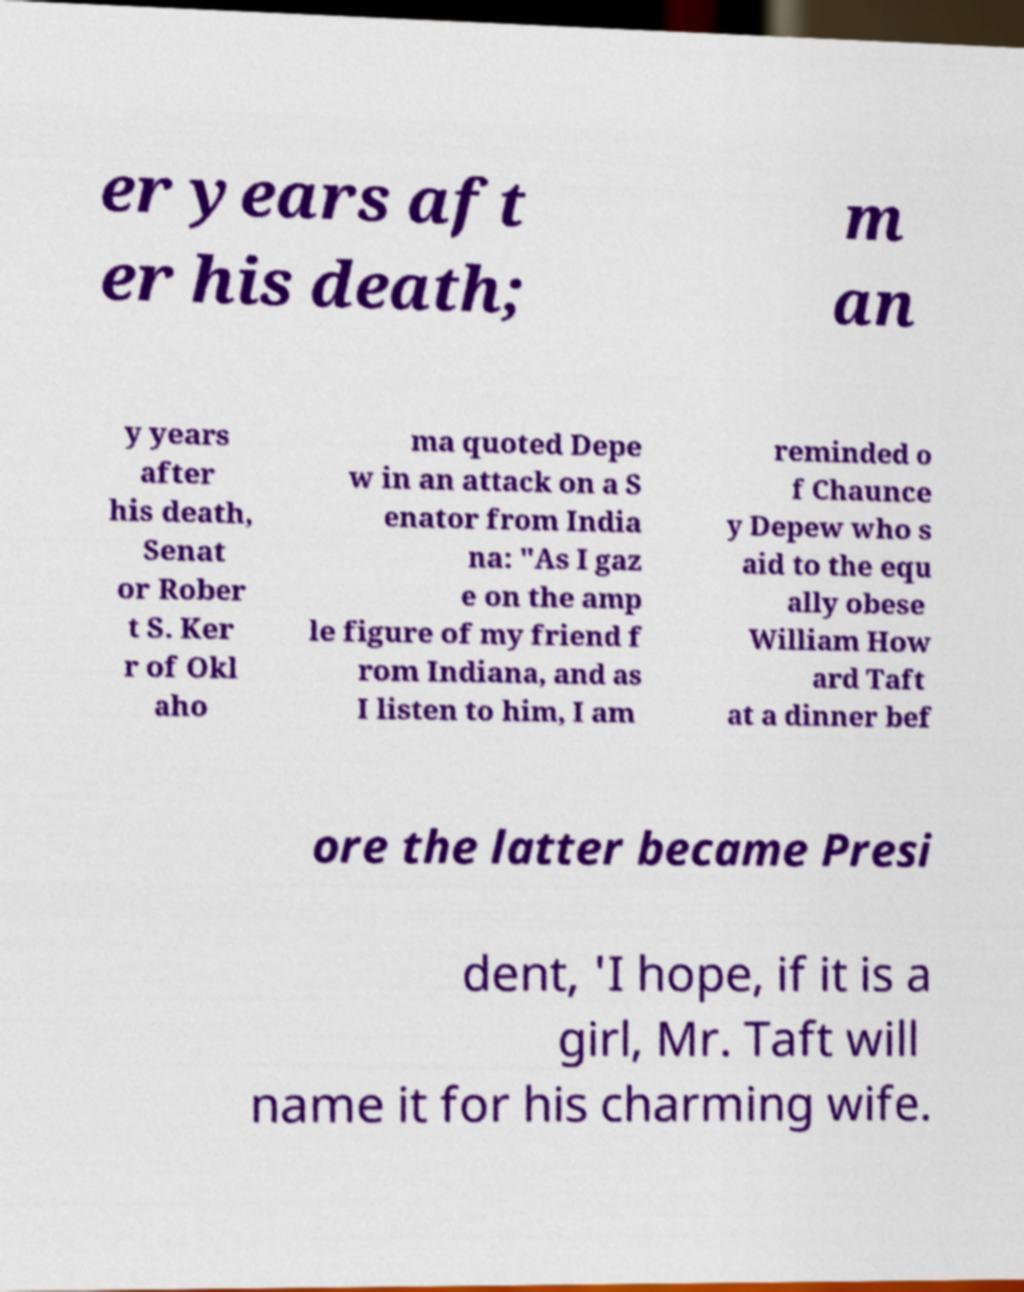Please read and relay the text visible in this image. What does it say? er years aft er his death; m an y years after his death, Senat or Rober t S. Ker r of Okl aho ma quoted Depe w in an attack on a S enator from India na: "As I gaz e on the amp le figure of my friend f rom Indiana, and as I listen to him, I am reminded o f Chaunce y Depew who s aid to the equ ally obese William How ard Taft at a dinner bef ore the latter became Presi dent, 'I hope, if it is a girl, Mr. Taft will name it for his charming wife. 